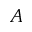<formula> <loc_0><loc_0><loc_500><loc_500>A</formula> 